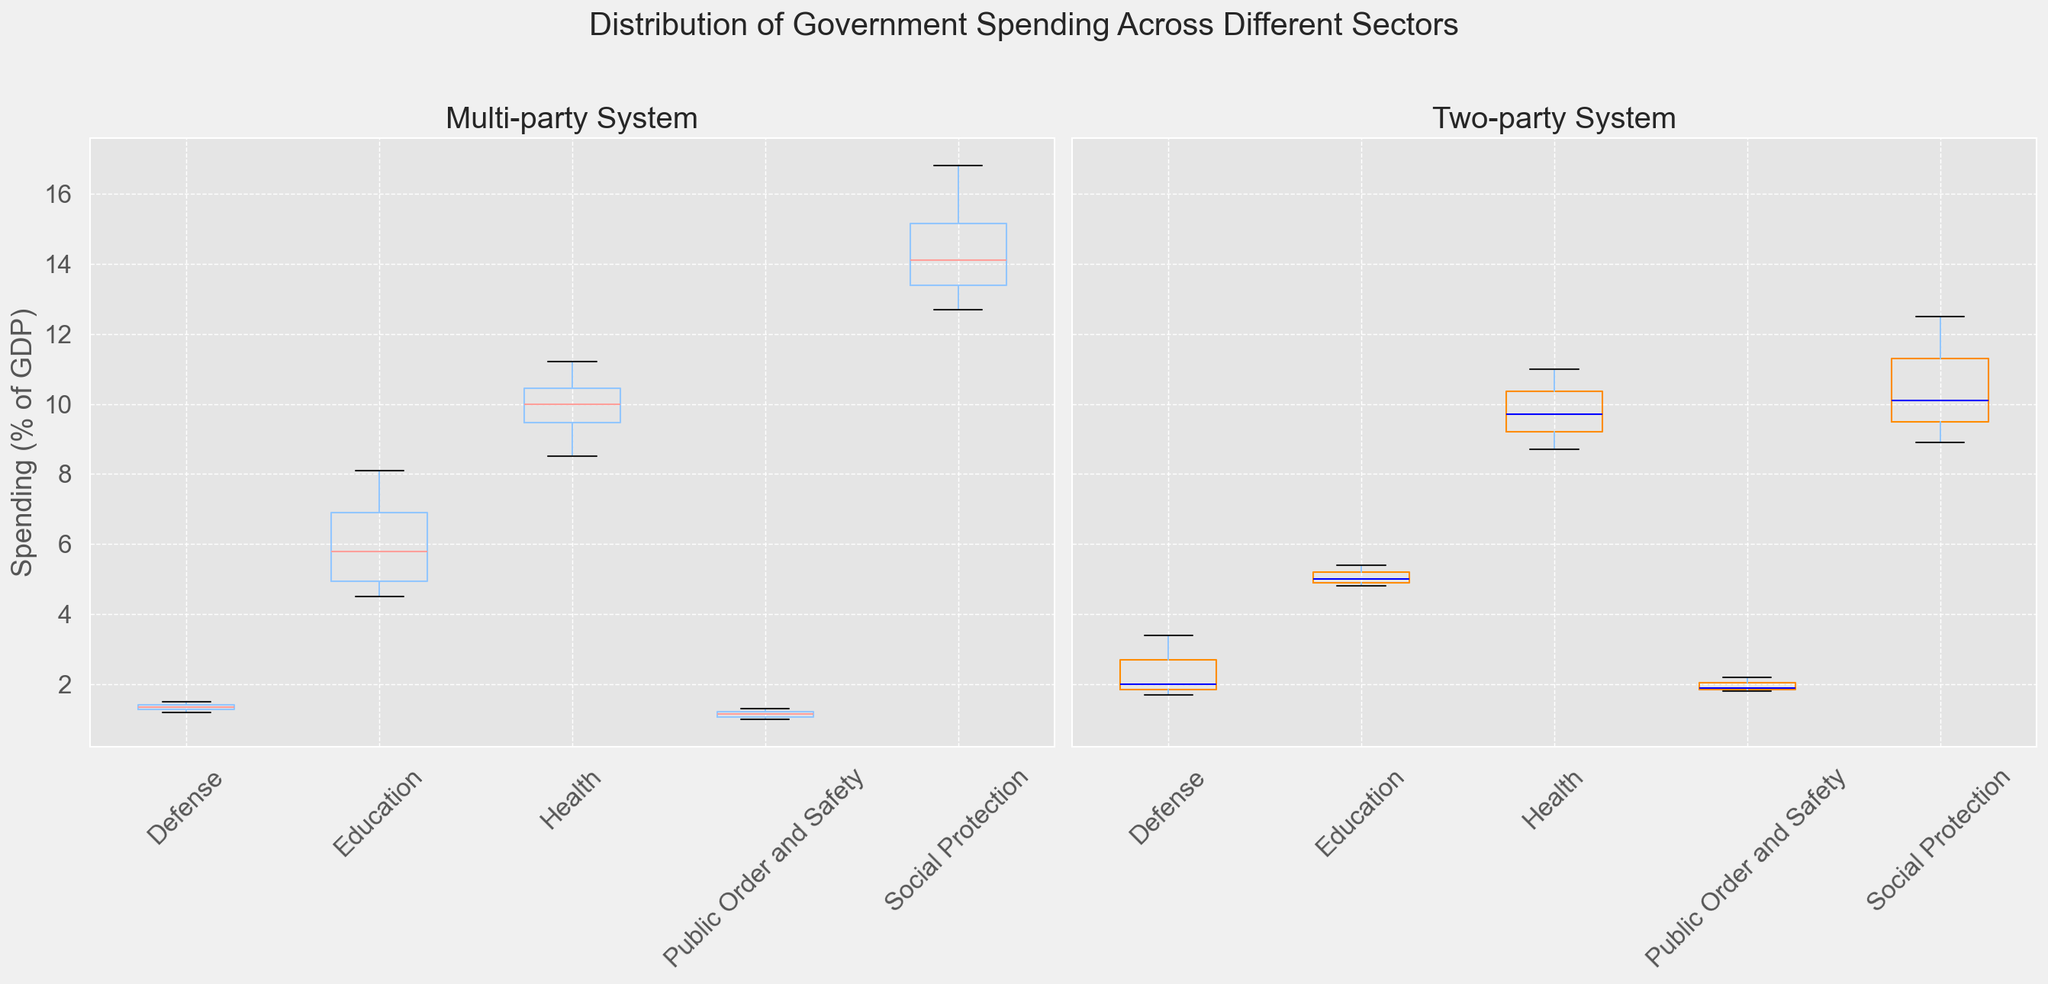Which system generally spends more on health? To determine which system spends more on health, compare the median spending on health across the two box plots. The median is indicated by the line within each box. For the multi-party system, the median health spending is higher than in the two-party system.
Answer: Multi-party Does the multi-party or two-party system have greater variability in education spending? To find the variability in education spending, look at the range of the box plots for education on both sides. The spread (distance between the lowest and highest values) for education in the two-party system is larger than that in the multi-party system, indicating greater variability.
Answer: Two-party Which sector has the lowest median spending in the two-party system? To find the sector with the lowest median spending in the two-party system, identify the box plot with the lowest central line. In the two-party system, the sector with the lowest median spending is Public Order and Safety.
Answer: Public Order and Safety Is the median spending on defense higher in the multi-party or two-party system? Compare the central line (median) within the box plots for defense spending on both sides. In the two-party system, the median spending on defense is higher than in the multi-party system.
Answer: Two-party Which system shows outliers in health spending? To determine if there are outliers in health spending, look for dots outside the whiskers in the box plots for health. In the two-party system, there is an outlier above the upper whisker indicating unusually high spending compared to the rest.
Answer: Two-party What is the difference in median spending on social protection between the two systems? Identify the median spending on social protection in both systems. The median is the line inside each box. In the multi-party system, it is higher. Calculate the difference: 14.6% (multi-party) - 10.1% (two-party) = 4.5%.
Answer: 4.5% How does the range of spending on public order and safety compare between the two systems? Compare the range (distance between the lowest and highest values) of the box plots for public order and safety. The range in the multi-party system is slightly smaller compared to the two-party system.
Answer: Multi-party Which sector shows the most consistent spending within countries in the multi-party system? The most consistent spending has the smallest range in the box plot. Public Order and Safety in the multi-party system has the smallest range, indicating consistent spending across countries.
Answer: Public Order and Safety Does any sector have overlapping interquartile ranges (IQR) between the two systems? Overlapping IQRs appear where the boxes overlap. For Health and Education, there is a slight overlap between the two systems.
Answer: Yes, Health and Education What is the maximum spending on education observed in the two-party system? Look at the highest value within the whiskers or outliers in the box plot for education in the two-party system. The maximum observed value is in Canada, at 5.4%.
Answer: 5.4% 